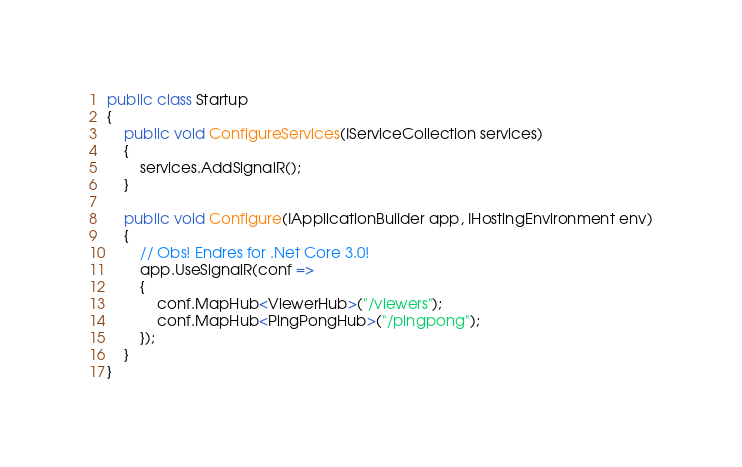<code> <loc_0><loc_0><loc_500><loc_500><_C#_>public class Startup
{    
    public void ConfigureServices(IServiceCollection services)
    {
        services.AddSignalR();
    }

    public void Configure(IApplicationBuilder app, IHostingEnvironment env)
    {
        // Obs! Endres for .Net Core 3.0!
        app.UseSignalR(conf =>
        {
            conf.MapHub<ViewerHub>("/viewers");
            conf.MapHub<PingPongHub>("/pingpong");
        });
    }
}</code> 